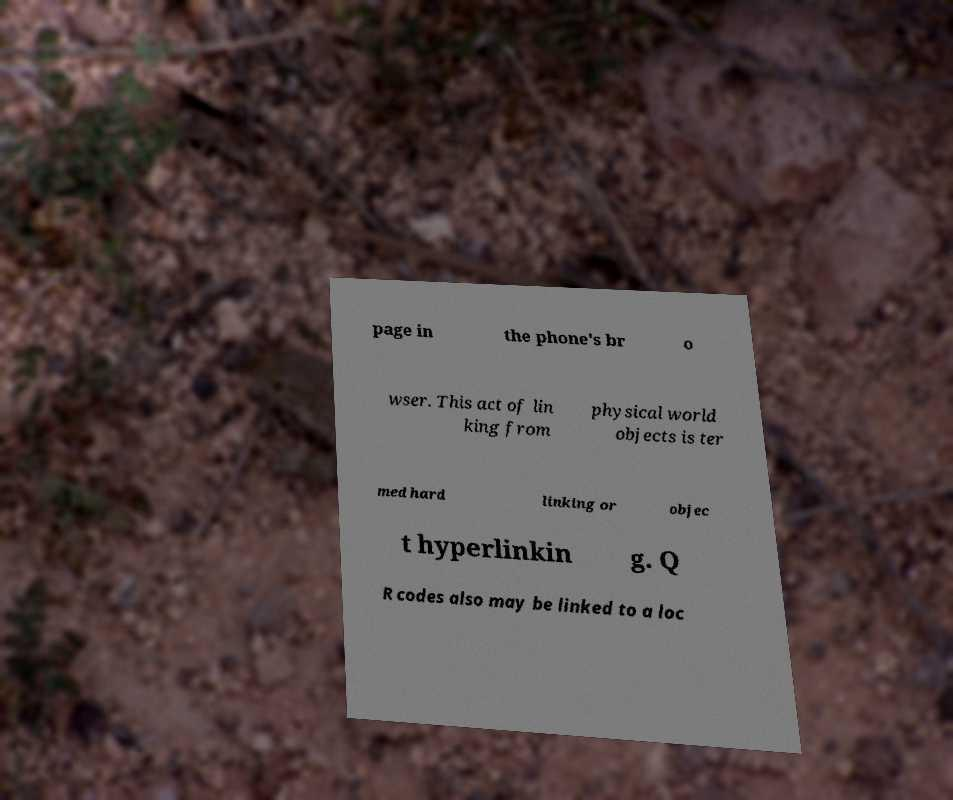Could you assist in decoding the text presented in this image and type it out clearly? page in the phone's br o wser. This act of lin king from physical world objects is ter med hard linking or objec t hyperlinkin g. Q R codes also may be linked to a loc 